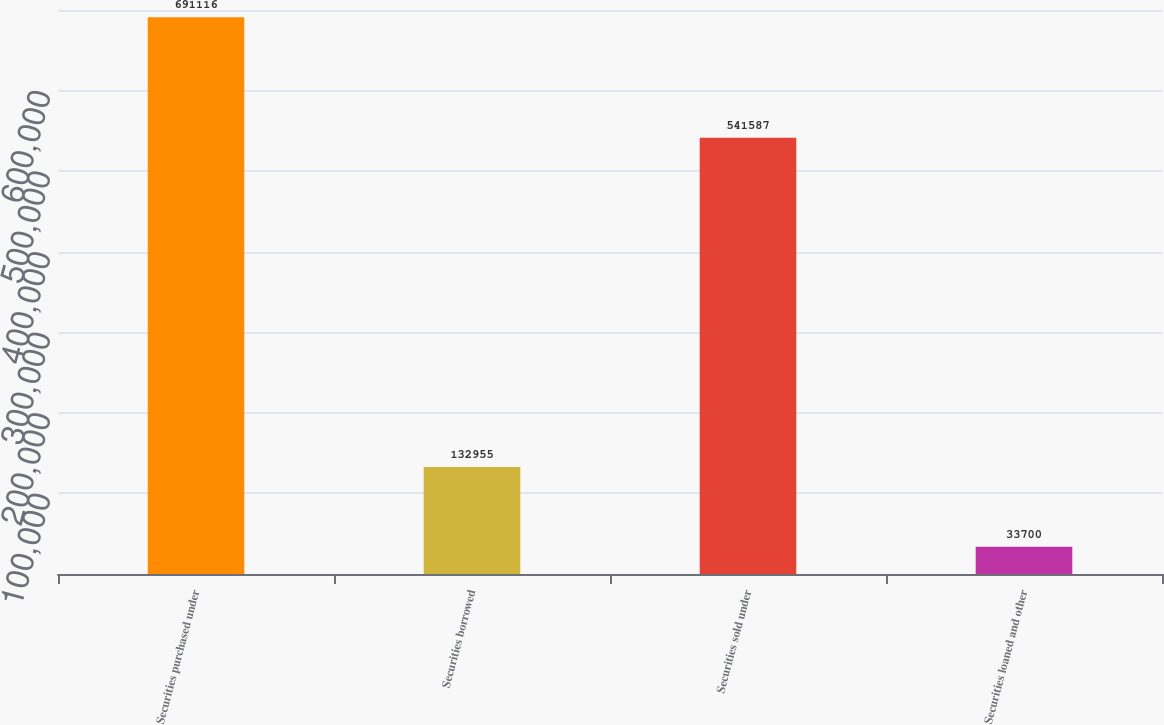<chart> <loc_0><loc_0><loc_500><loc_500><bar_chart><fcel>Securities purchased under<fcel>Securities borrowed<fcel>Securities sold under<fcel>Securities loaned and other<nl><fcel>691116<fcel>132955<fcel>541587<fcel>33700<nl></chart> 